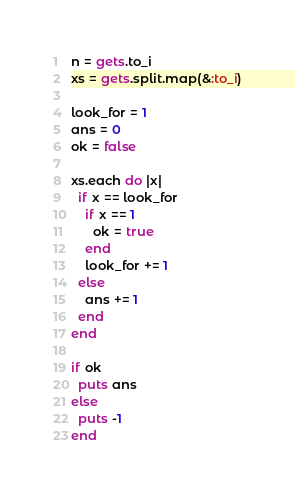<code> <loc_0><loc_0><loc_500><loc_500><_Ruby_>n = gets.to_i
xs = gets.split.map(&:to_i)

look_for = 1
ans = 0
ok = false

xs.each do |x|
  if x == look_for
    if x == 1
      ok = true
    end
    look_for += 1
  else
    ans += 1
  end
end

if ok
  puts ans
else
  puts -1
end
</code> 